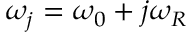<formula> <loc_0><loc_0><loc_500><loc_500>\omega _ { j } = \omega _ { 0 } + j \omega _ { R }</formula> 